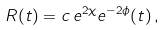Convert formula to latex. <formula><loc_0><loc_0><loc_500><loc_500>R ( t ) = c \, e ^ { 2 \chi } e ^ { - 2 \phi } ( t ) \, ,</formula> 